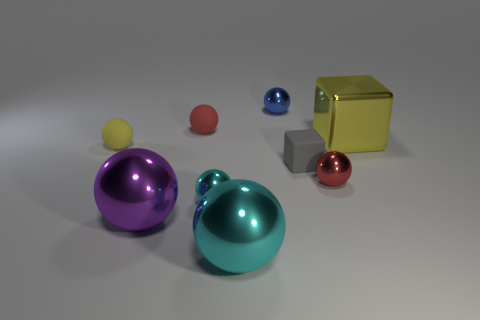Subtract all tiny cyan spheres. How many spheres are left? 6 Subtract all green cylinders. How many cyan spheres are left? 2 Add 1 big yellow metallic cubes. How many objects exist? 10 Subtract all gray cubes. How many cubes are left? 1 Subtract all spheres. How many objects are left? 2 Add 3 red spheres. How many red spheres exist? 5 Subtract 1 yellow balls. How many objects are left? 8 Subtract all gray balls. Subtract all gray cubes. How many balls are left? 7 Subtract all gray cubes. Subtract all cyan things. How many objects are left? 6 Add 9 red metal things. How many red metal things are left? 10 